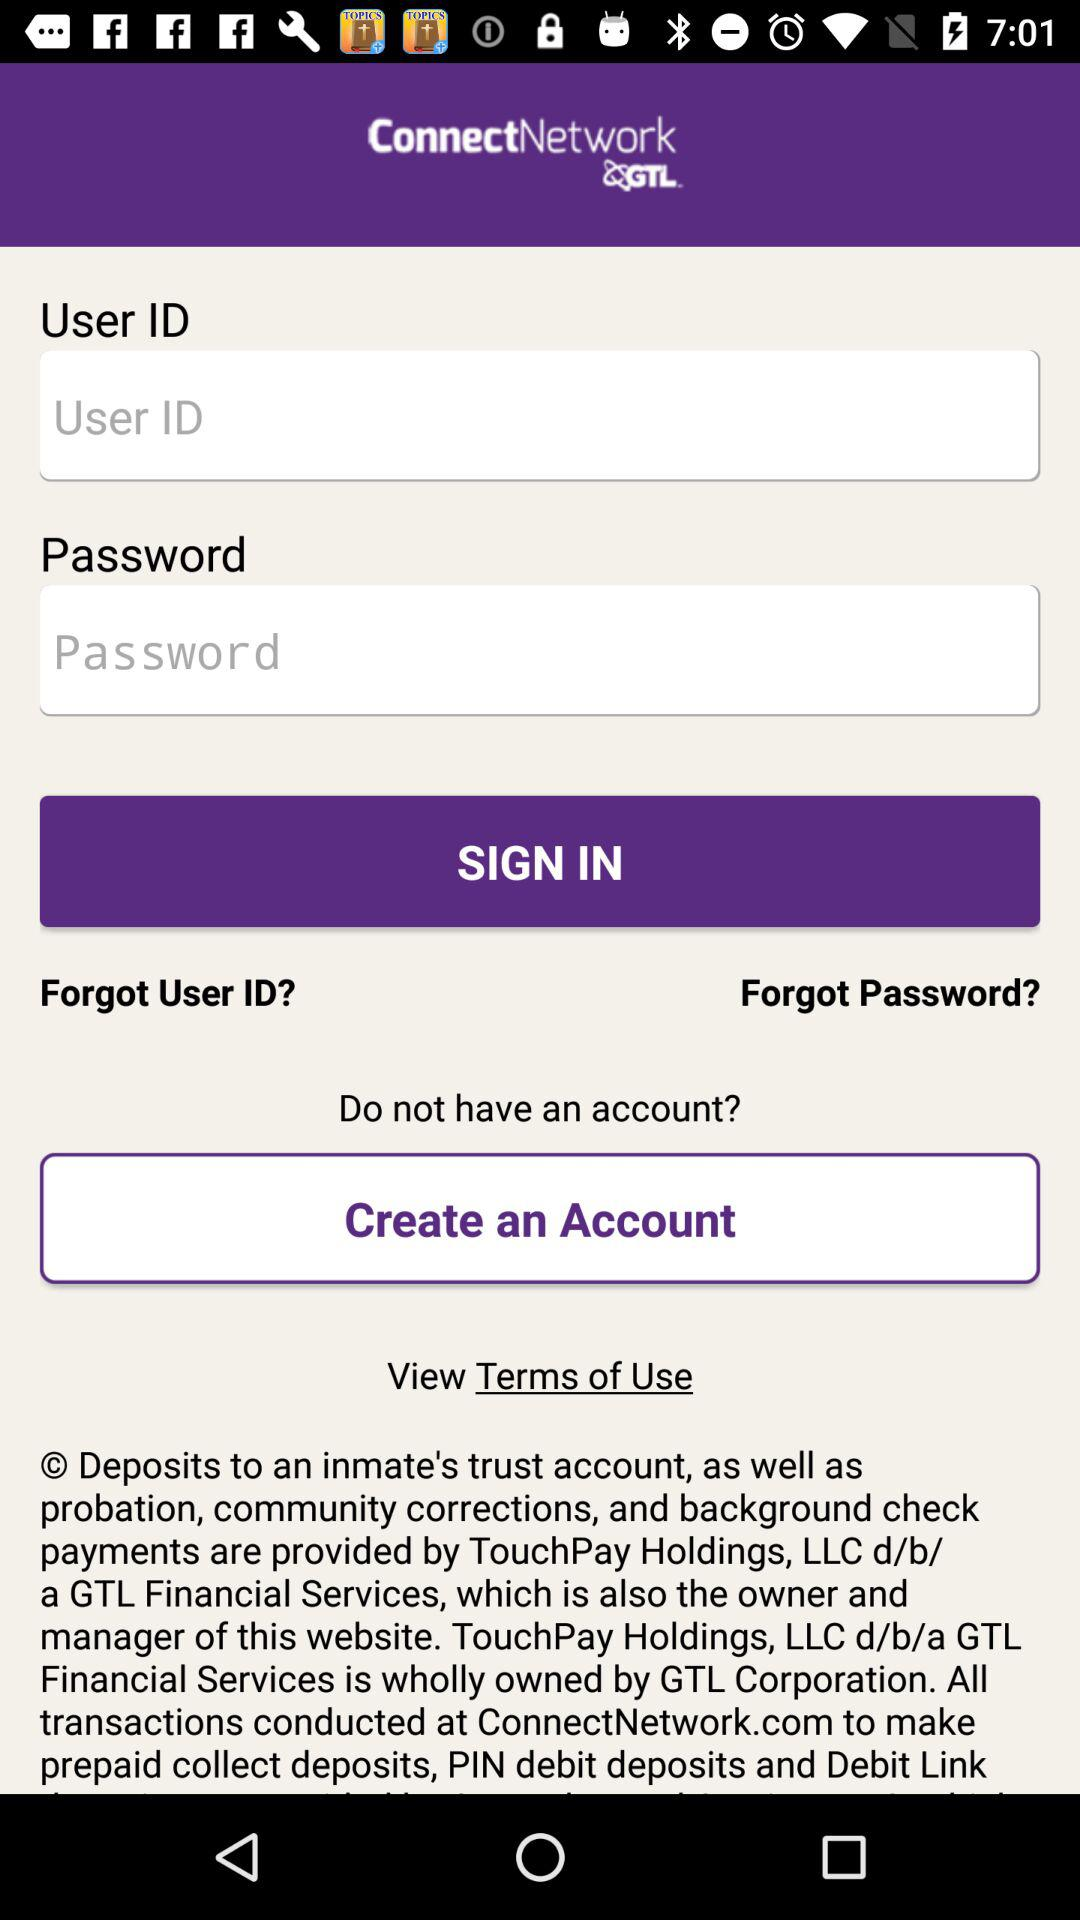What is the name of the application? The name of the application is "ConnectNetwork by GTL". 